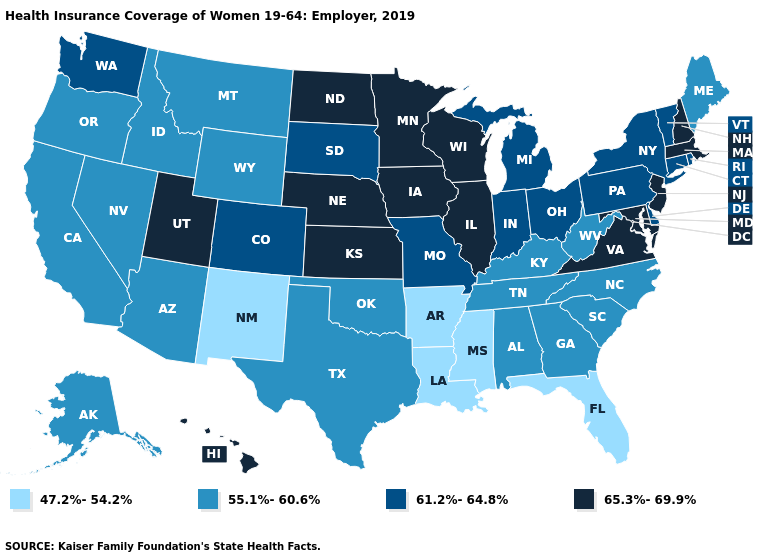What is the lowest value in states that border Idaho?
Short answer required. 55.1%-60.6%. Name the states that have a value in the range 55.1%-60.6%?
Give a very brief answer. Alabama, Alaska, Arizona, California, Georgia, Idaho, Kentucky, Maine, Montana, Nevada, North Carolina, Oklahoma, Oregon, South Carolina, Tennessee, Texas, West Virginia, Wyoming. What is the lowest value in the USA?
Give a very brief answer. 47.2%-54.2%. What is the lowest value in the West?
Write a very short answer. 47.2%-54.2%. Does Mississippi have the lowest value in the USA?
Quick response, please. Yes. What is the value of North Carolina?
Give a very brief answer. 55.1%-60.6%. Name the states that have a value in the range 55.1%-60.6%?
Quick response, please. Alabama, Alaska, Arizona, California, Georgia, Idaho, Kentucky, Maine, Montana, Nevada, North Carolina, Oklahoma, Oregon, South Carolina, Tennessee, Texas, West Virginia, Wyoming. Which states have the lowest value in the USA?
Keep it brief. Arkansas, Florida, Louisiana, Mississippi, New Mexico. Does Minnesota have the highest value in the USA?
Quick response, please. Yes. How many symbols are there in the legend?
Short answer required. 4. Among the states that border Montana , which have the lowest value?
Concise answer only. Idaho, Wyoming. Does Wisconsin have the same value as Alaska?
Answer briefly. No. What is the lowest value in the Northeast?
Short answer required. 55.1%-60.6%. Among the states that border New Hampshire , which have the lowest value?
Quick response, please. Maine. What is the value of Tennessee?
Short answer required. 55.1%-60.6%. 